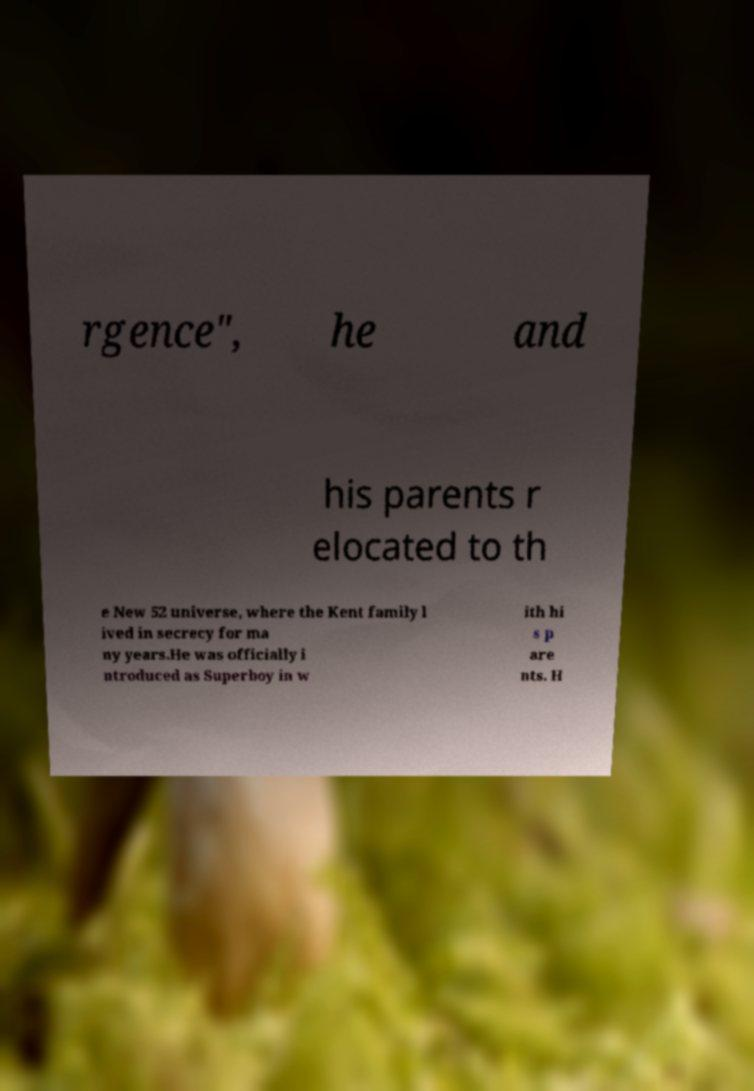What messages or text are displayed in this image? I need them in a readable, typed format. rgence", he and his parents r elocated to th e New 52 universe, where the Kent family l ived in secrecy for ma ny years.He was officially i ntroduced as Superboy in w ith hi s p are nts. H 